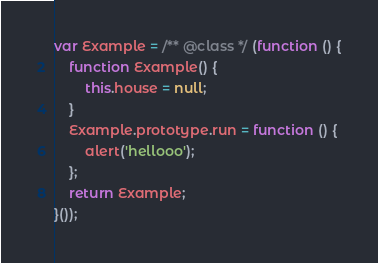<code> <loc_0><loc_0><loc_500><loc_500><_JavaScript_>var Example = /** @class */ (function () {
    function Example() {
        this.house = null;
    }
    Example.prototype.run = function () {
        alert('hellooo');
    };
    return Example;
}());
</code> 